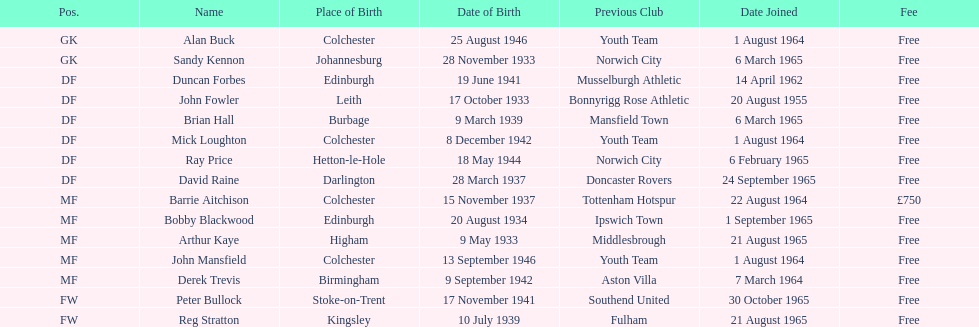For each player, when did they enroll? 1 August 1964, 6 March 1965, 14 April 1962, 20 August 1955, 6 March 1965, 1 August 1964, 6 February 1965, 24 September 1965, 22 August 1964, 1 September 1965, 21 August 1965, 1 August 1964, 7 March 1964, 30 October 1965, 21 August 1965. Out of all, who has the most senior joining date? 20 August 1955. 